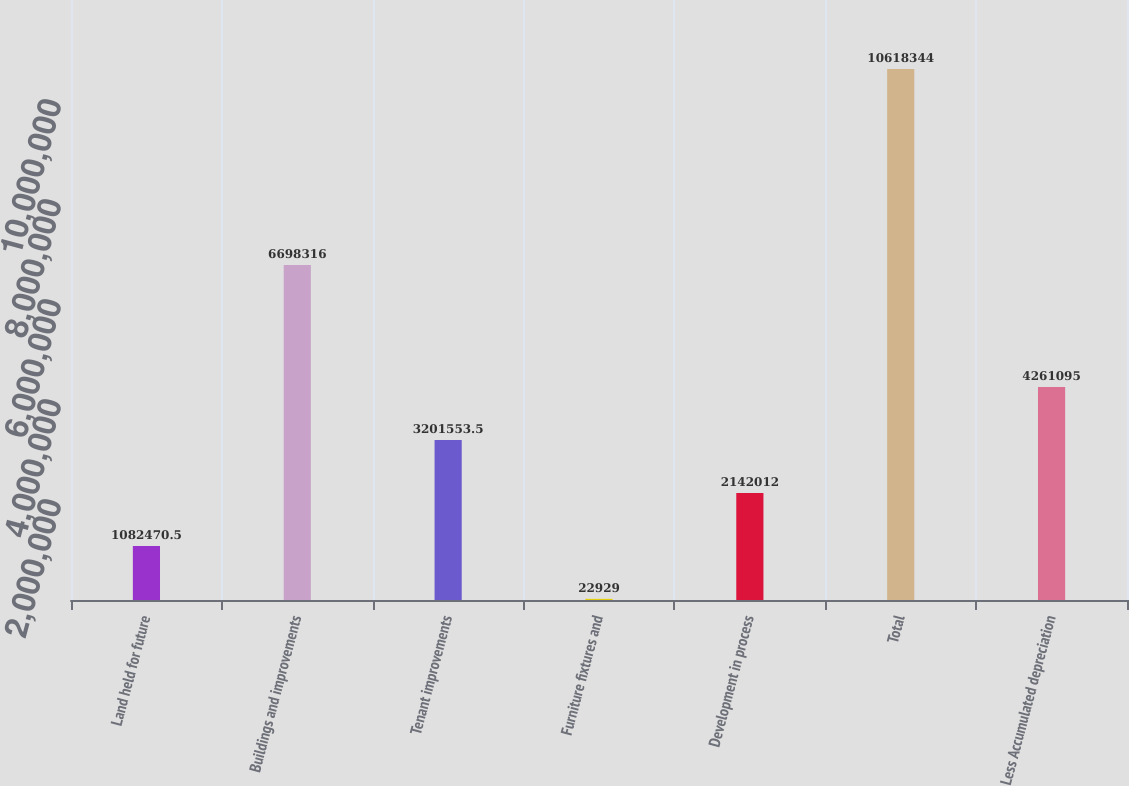Convert chart. <chart><loc_0><loc_0><loc_500><loc_500><bar_chart><fcel>Land held for future<fcel>Buildings and improvements<fcel>Tenant improvements<fcel>Furniture fixtures and<fcel>Development in process<fcel>Total<fcel>Less Accumulated depreciation<nl><fcel>1.08247e+06<fcel>6.69832e+06<fcel>3.20155e+06<fcel>22929<fcel>2.14201e+06<fcel>1.06183e+07<fcel>4.2611e+06<nl></chart> 